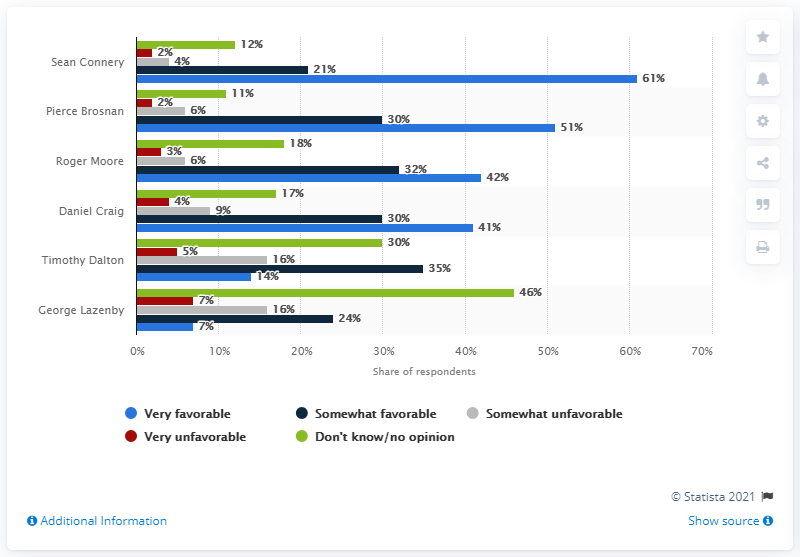Who was the most favorable James Bond actor? According to the bar chart shown in the image, Sean Connery is indeed seen as the most favorable James Bond actor, with 61% of respondents rating him very favorably. This reflects his significant popularity compared to other actors portrayed in the role. 